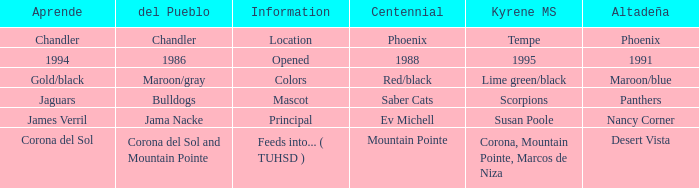Which Centennial has a Altadeña of panthers? Saber Cats. 